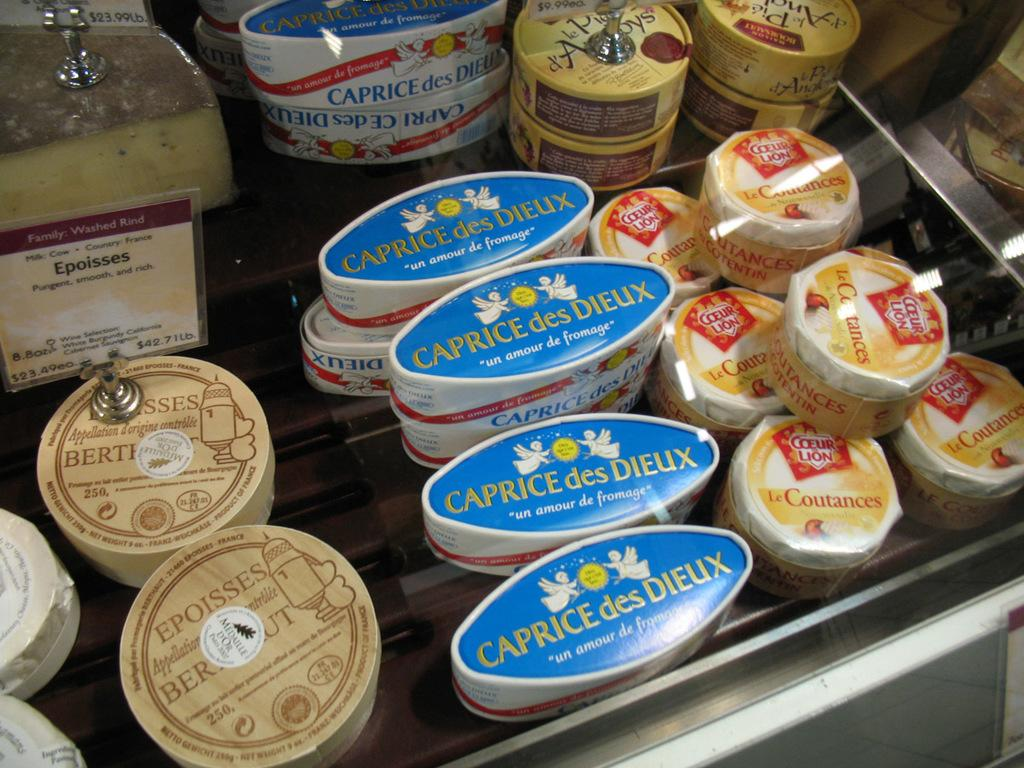What objects are visible in the image? There are boxes in the image. How are the boxes arranged or contained? The boxes are placed inside a glass container. Are there any additional details about the boxes? Yes, there are price tags on the boxes. How many rabbits are visible on the canvas in the image? There are no rabbits or canvas present in the image; it features boxes inside a glass container with price tags. 